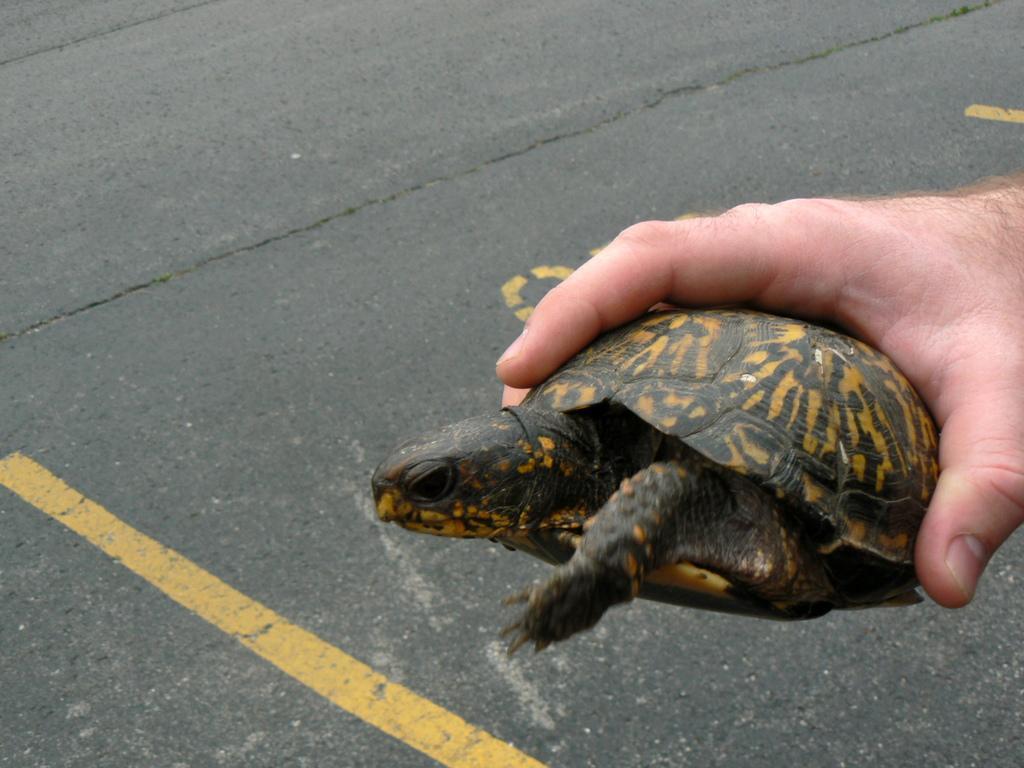Could you give a brief overview of what you see in this image? On the right side of the image, we can see a human hand is holding a tortoise. Background there is a road. On the road, we can see yellow color lines and some text. 